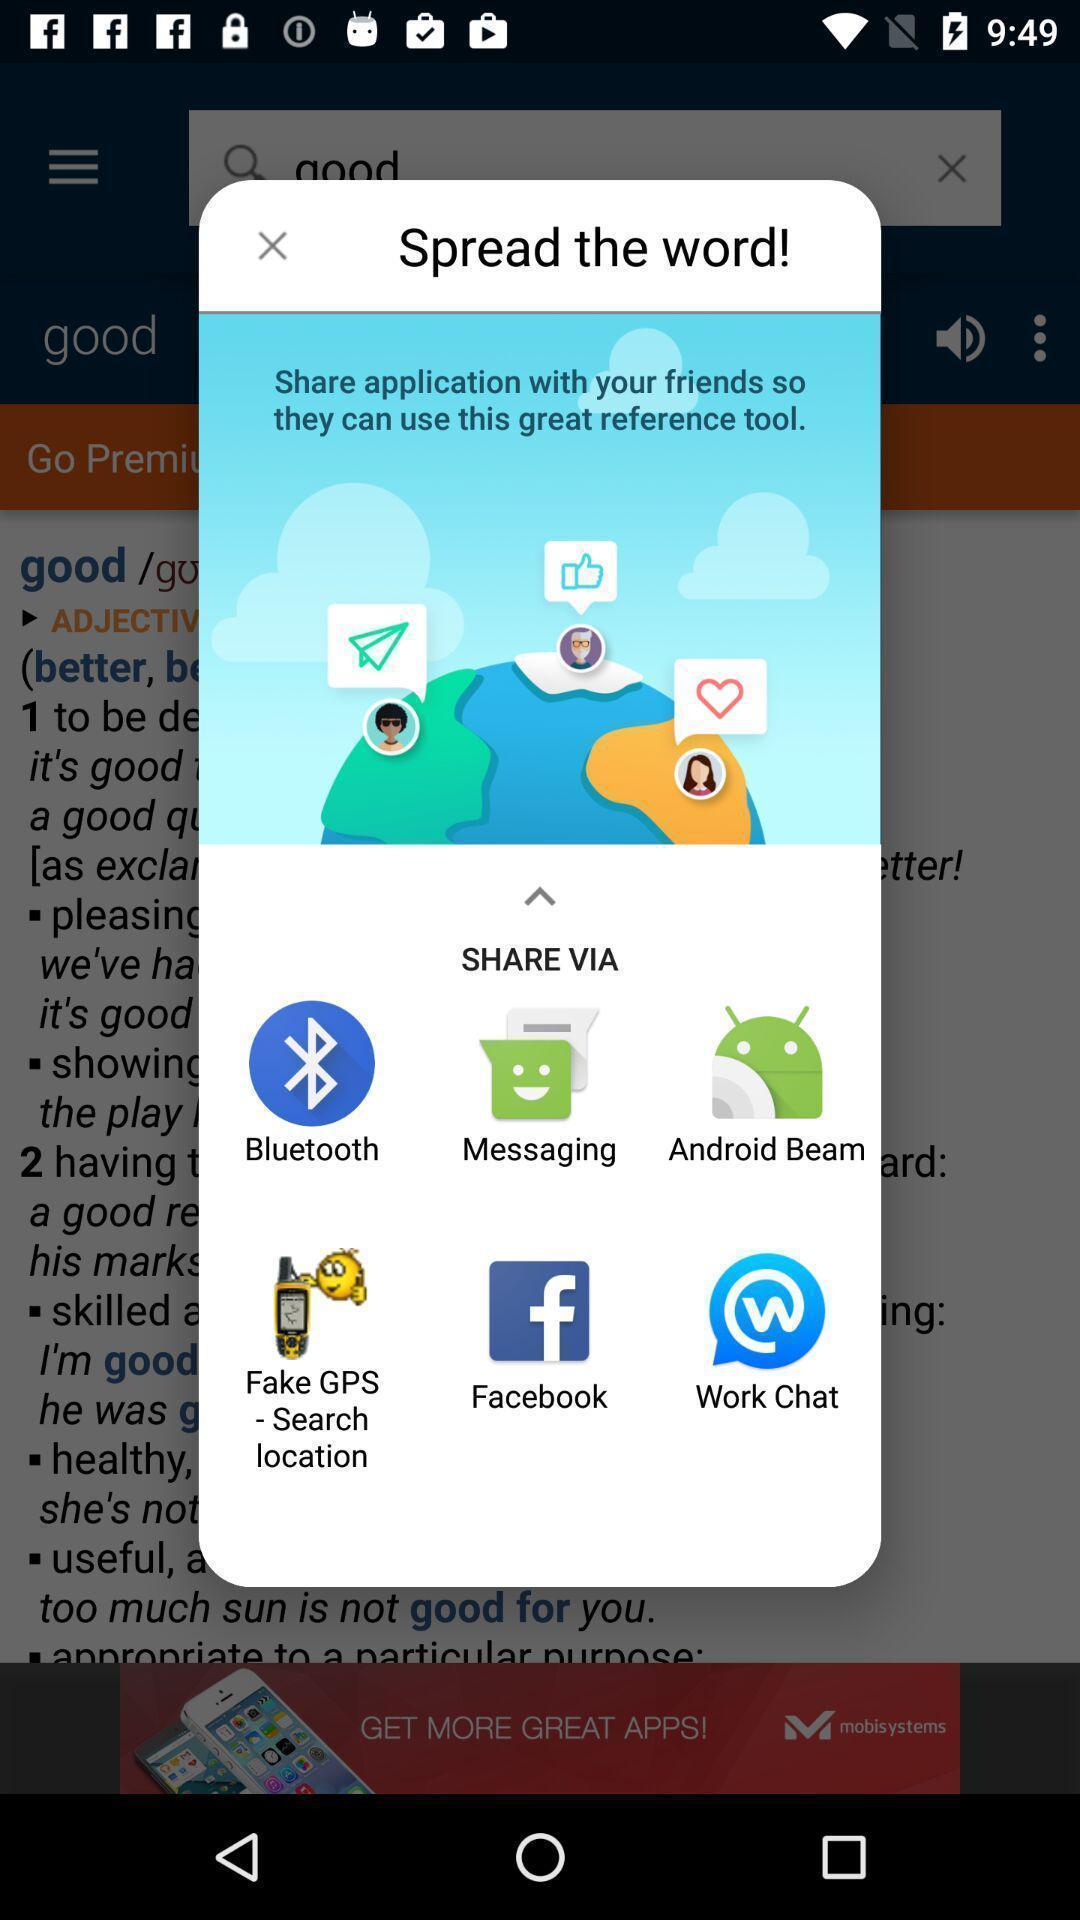Describe the content in this image. Popup showing about different apps to share. 